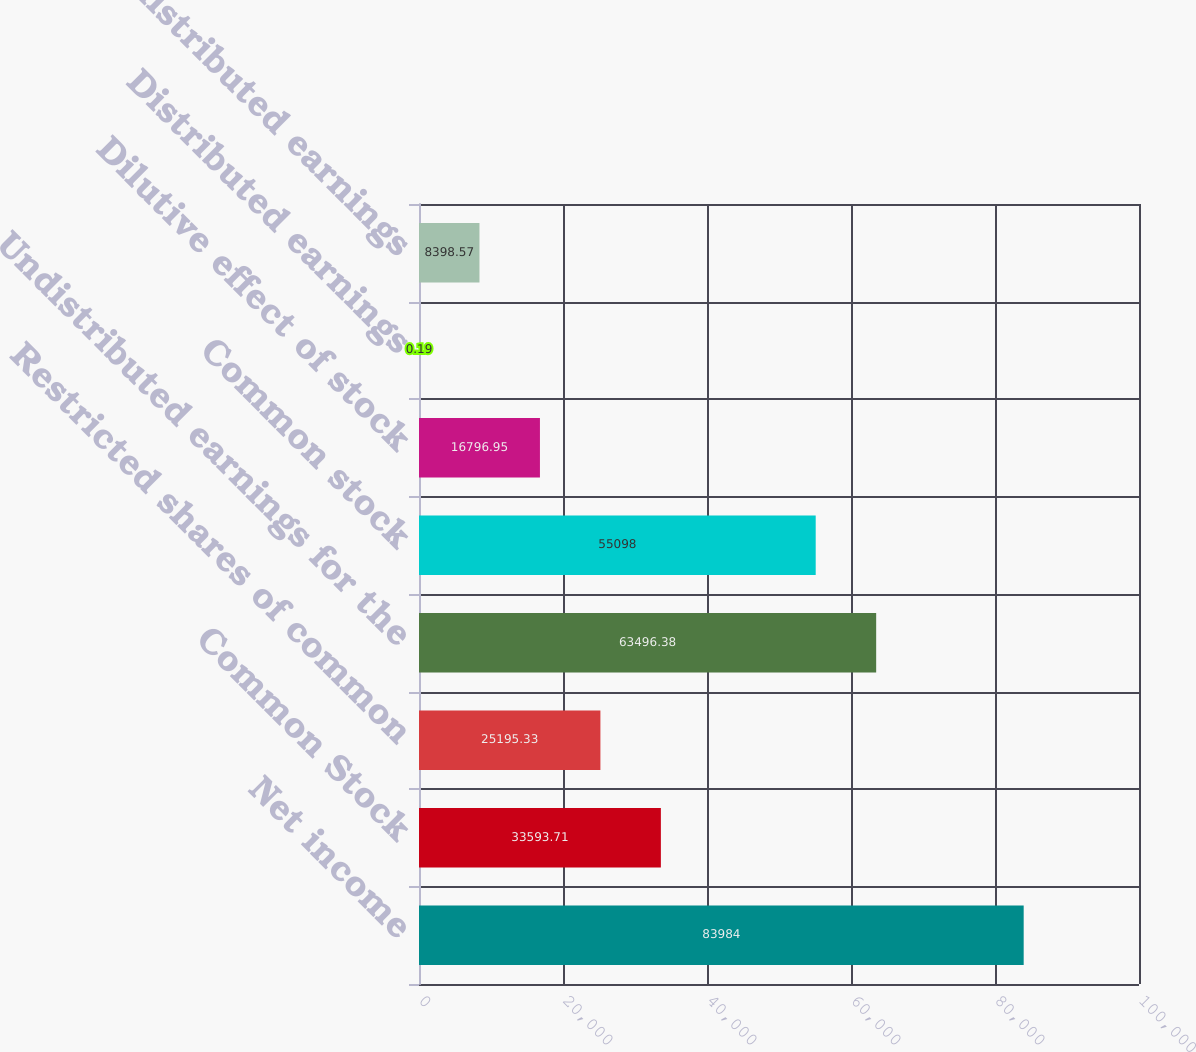Convert chart. <chart><loc_0><loc_0><loc_500><loc_500><bar_chart><fcel>Net income<fcel>Common Stock<fcel>Restricted shares of common<fcel>Undistributed earnings for the<fcel>Common stock<fcel>Dilutive effect of stock<fcel>Distributed earnings<fcel>Undistributed earnings<nl><fcel>83984<fcel>33593.7<fcel>25195.3<fcel>63496.4<fcel>55098<fcel>16797<fcel>0.19<fcel>8398.57<nl></chart> 